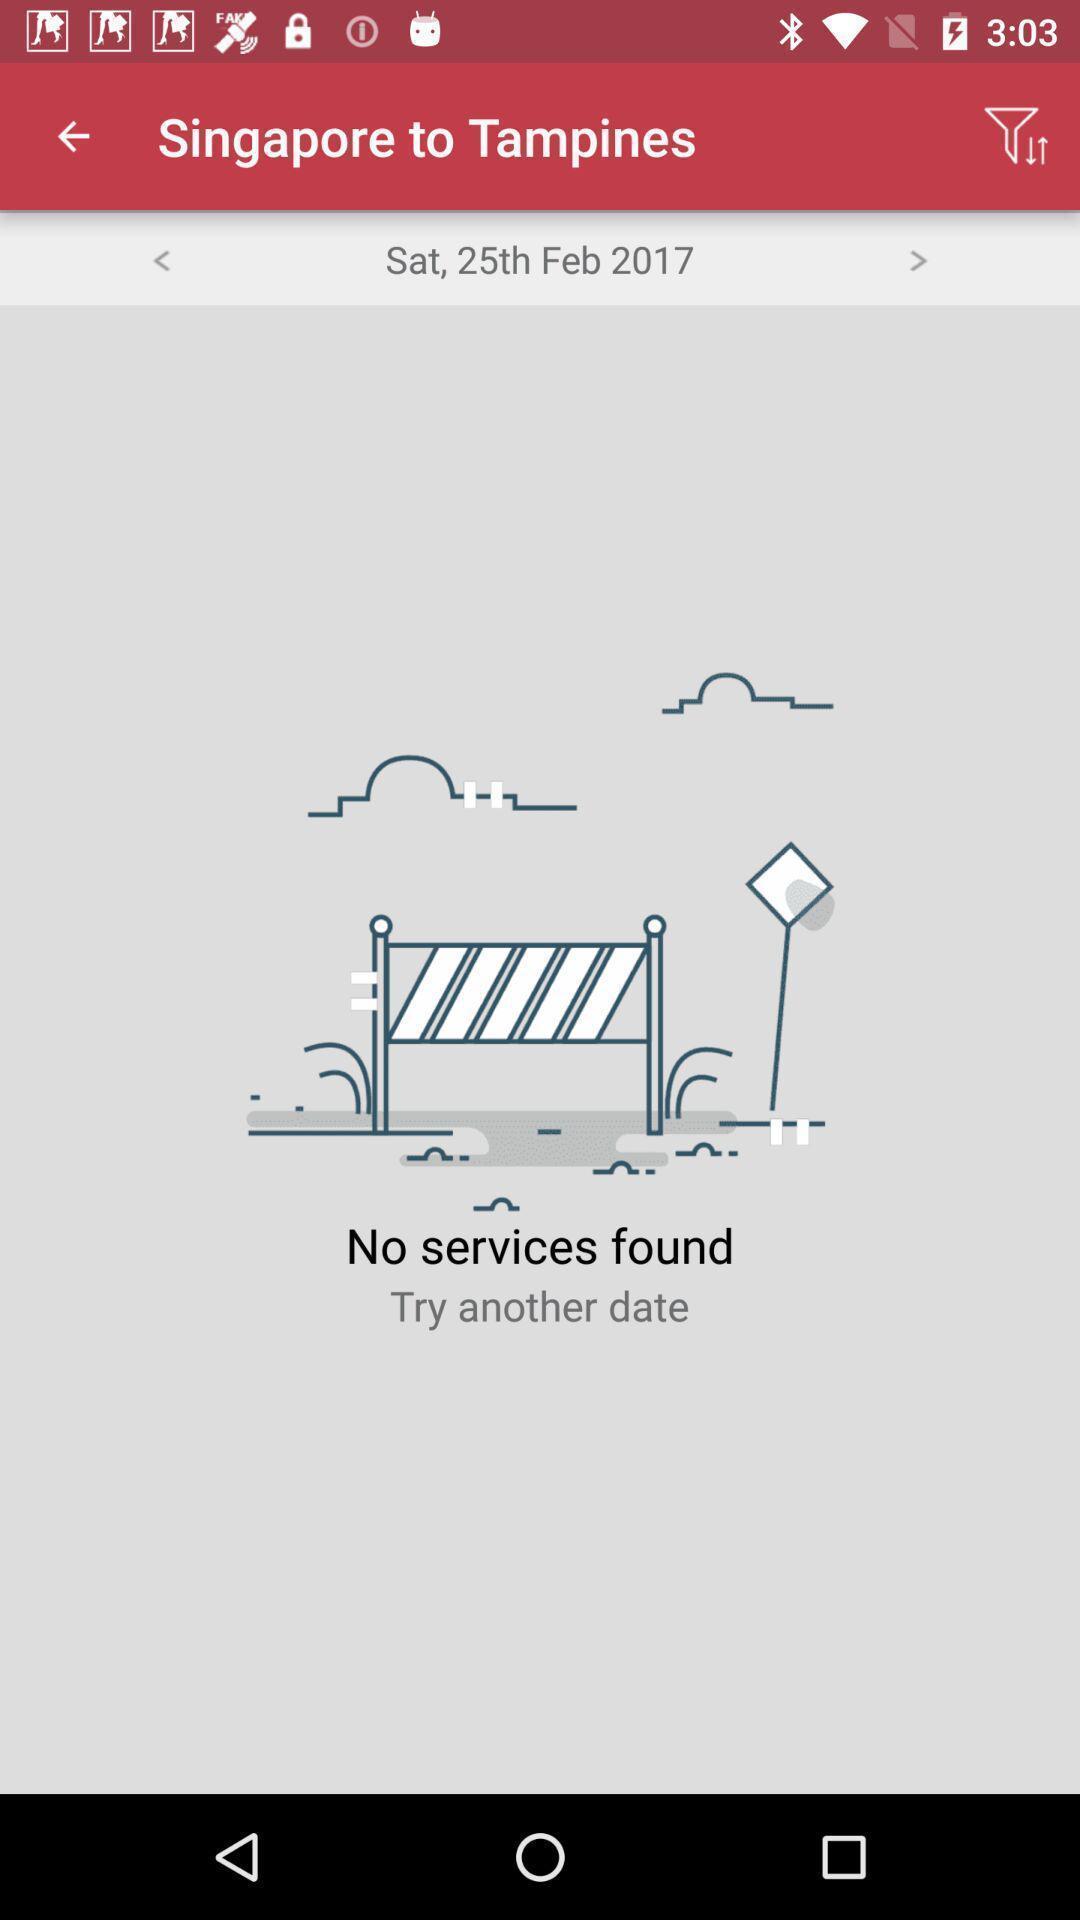Describe the key features of this screenshot. Screen displaying booking bus tickets app. 